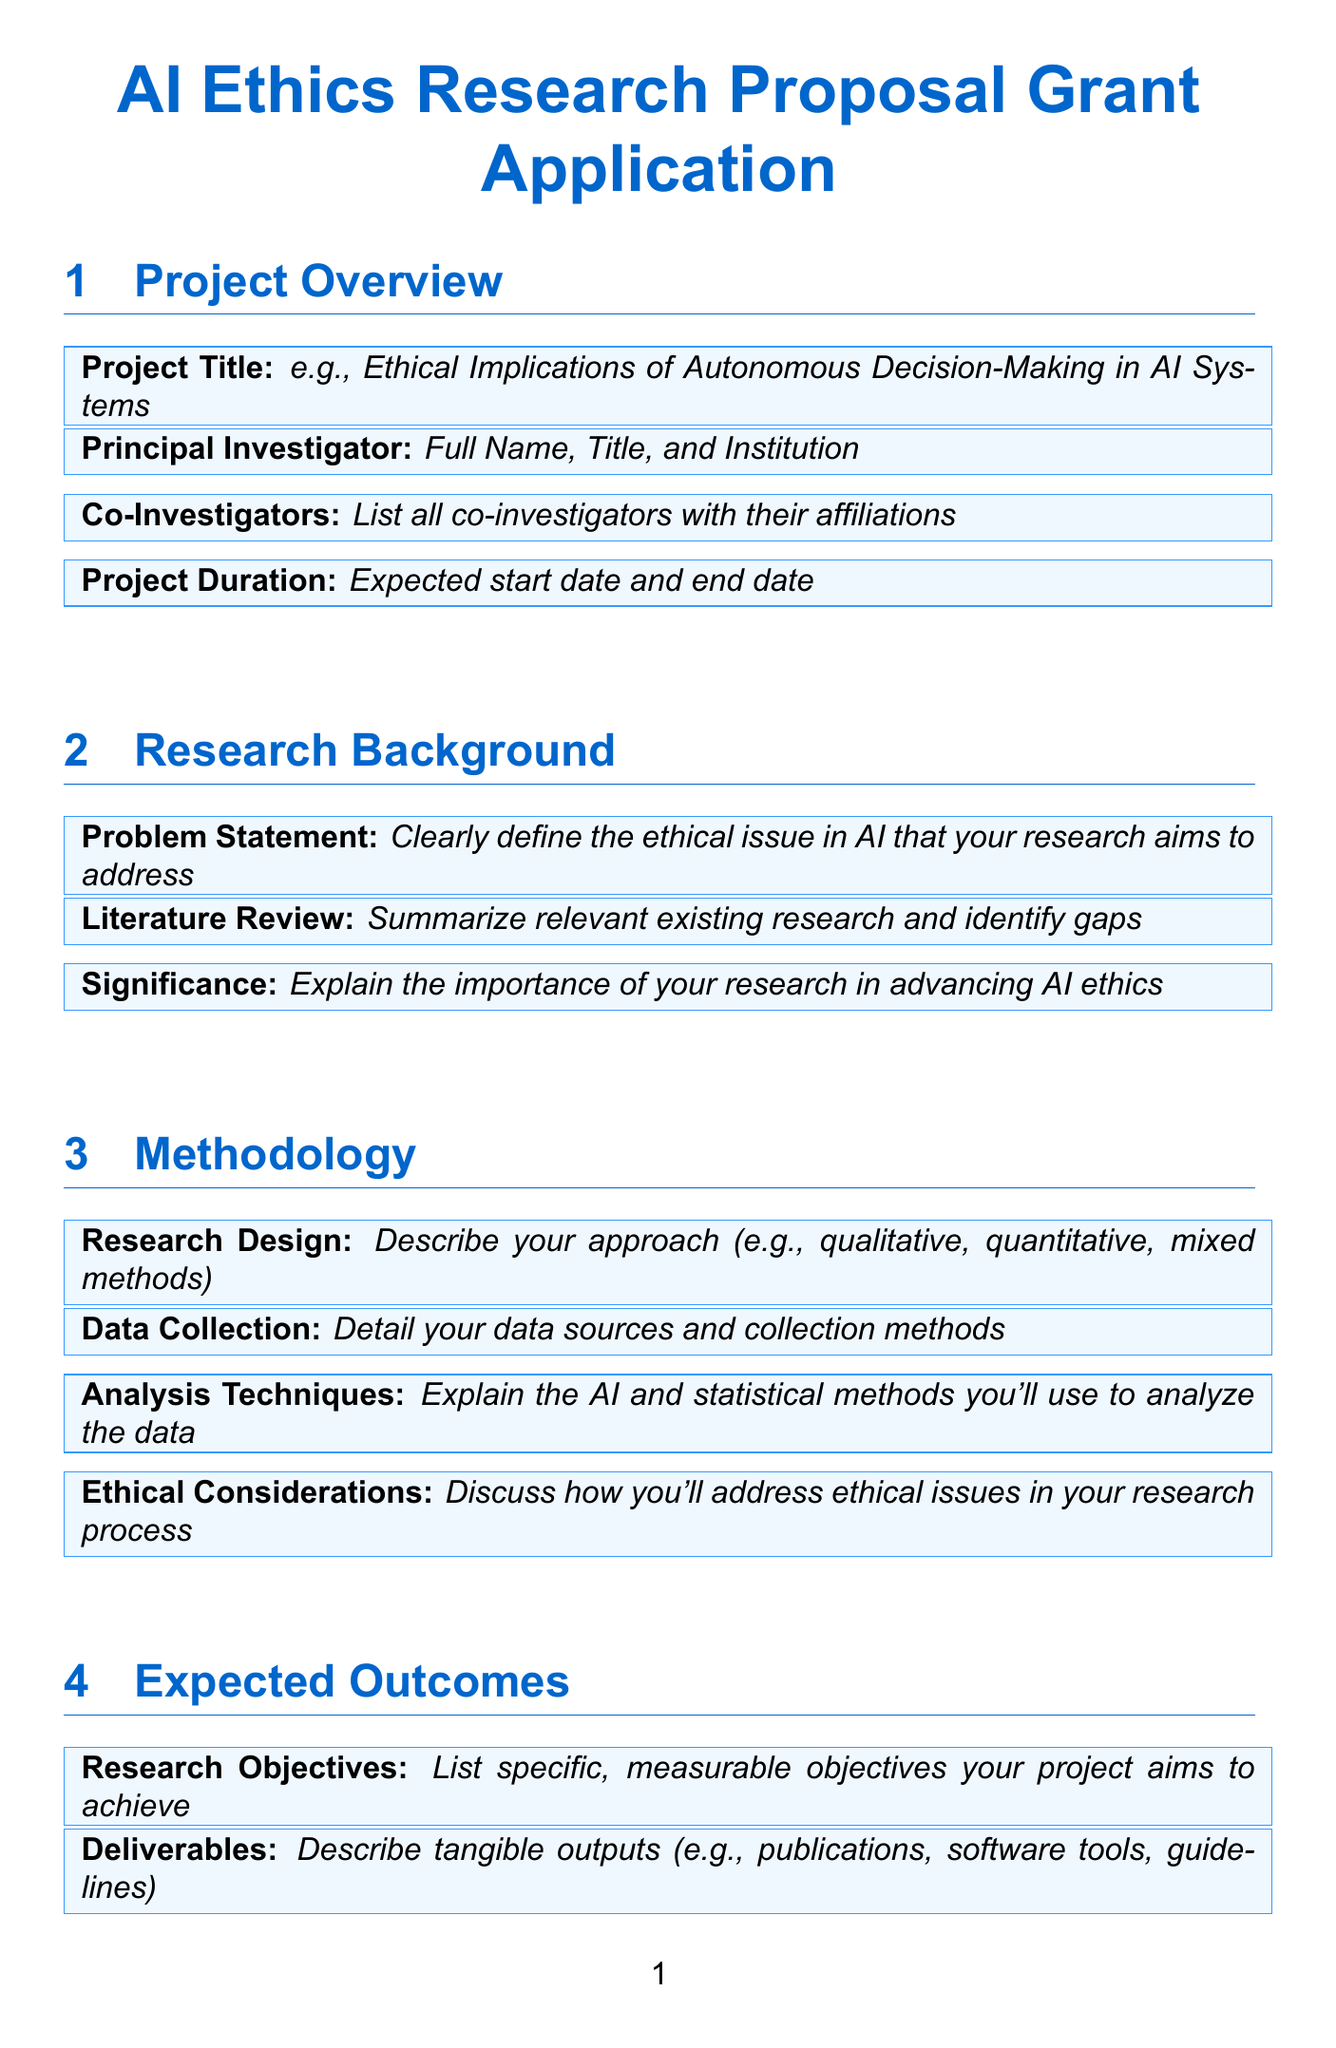What is the project title? The project title is expected to be provided in the field specifying it in the document.
Answer: Ethical Implications of Autonomous Decision-Making in AI Systems Who is the principal investigator? The principal investigator's name, title, and institution is requested in the project overview section.
Answer: Full Name, Title, and Institution What are the expected project start and end dates? This information is included in the project duration field of the document.
Answer: Expected start date and end date What is one of the research objectives? The research objectives should be specific and measurable as listed in the expected outcomes section.
Answer: List specific, measurable objectives your project aims to achieve What methodologies might be used for data analysis? This is addressed in the analysis techniques field of the methodology section, where specifics of methods are discussed.
Answer: Explain the AI and statistical methods you'll use to analyze the data What types of costs are included in the budget allocation? The budget section specifies various types of expenses associated with the project.
Answer: Salaries and benefits for researchers and assistants, hardware and software, conferences, printing costs, other expenses What is the significance of the proposed research? The significance is required to explain the importance of the research in advancing AI ethics.
Answer: Explain the importance of your research in advancing AI ethics Which journals or conferences are targeted for publication? This is found in the academic publications field within the dissemination plan section of the document.
Answer: Target journals and conferences How will the research team collaborate? Explaining the collaboration plan is specified in the research team section, detailing teamwork and task distribution.
Answer: Explain how the team will work together and distribute tasks 